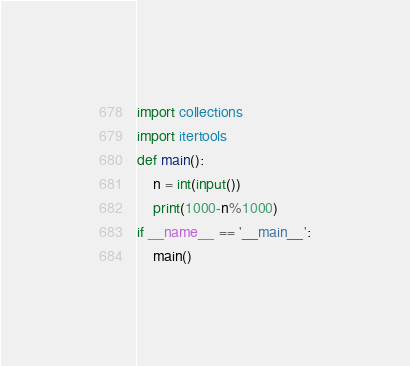<code> <loc_0><loc_0><loc_500><loc_500><_Python_>import collections
import itertools
def main():
    n = int(input())
    print(1000-n%1000)
if __name__ == '__main__':
    main()
</code> 